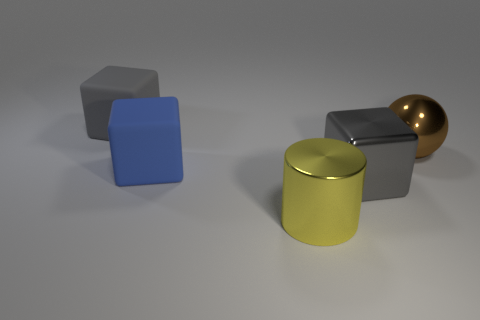Does this image appear to be computer-generated or photographed in a real environment? This image appears to be computer-generated. The perfect geometric shapes and uniform lighting suggest a digital rendering rather than a photograph taken in a natural setting. 